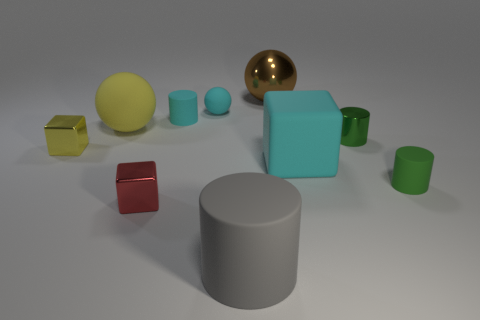Subtract all blue cylinders. Subtract all green balls. How many cylinders are left? 4 Subtract all spheres. How many objects are left? 7 Add 8 yellow shiny cubes. How many yellow shiny cubes are left? 9 Add 9 small yellow shiny objects. How many small yellow shiny objects exist? 10 Subtract 1 cyan blocks. How many objects are left? 9 Subtract all big cylinders. Subtract all small red cubes. How many objects are left? 8 